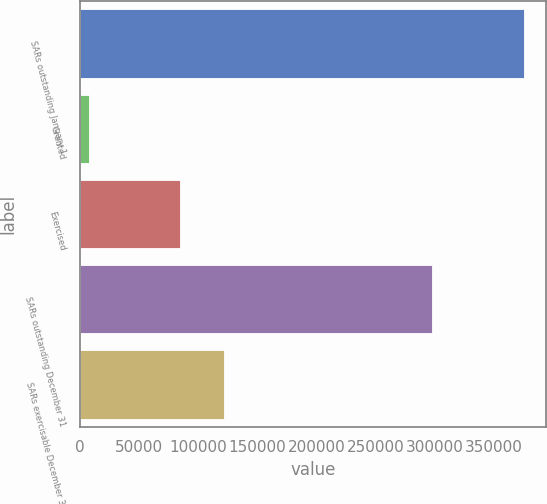Convert chart to OTSL. <chart><loc_0><loc_0><loc_500><loc_500><bar_chart><fcel>SARs outstanding January 1<fcel>Granted<fcel>Exercised<fcel>SARs outstanding December 31<fcel>SARs exercisable December 31<nl><fcel>375104<fcel>7733<fcel>85123<fcel>297714<fcel>121860<nl></chart> 